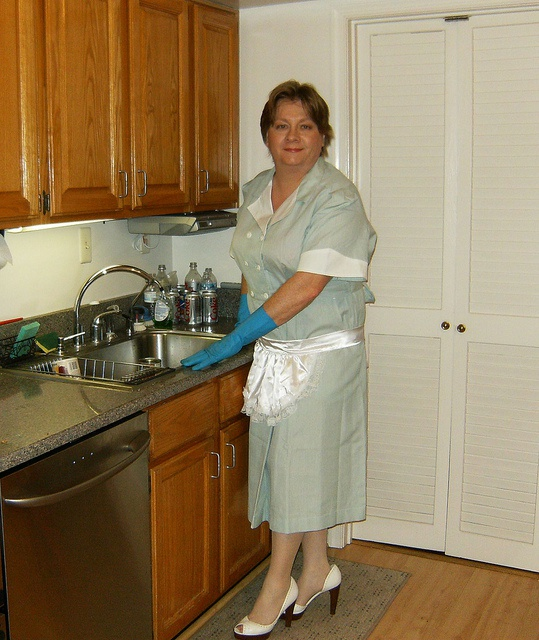Describe the objects in this image and their specific colors. I can see people in brown, darkgray, gray, and lightgray tones, sink in brown, gray, black, and darkgreen tones, bottle in brown, gray, black, and darkgray tones, bottle in brown, gray, black, darkgreen, and darkgray tones, and cup in brown, tan, and gray tones in this image. 